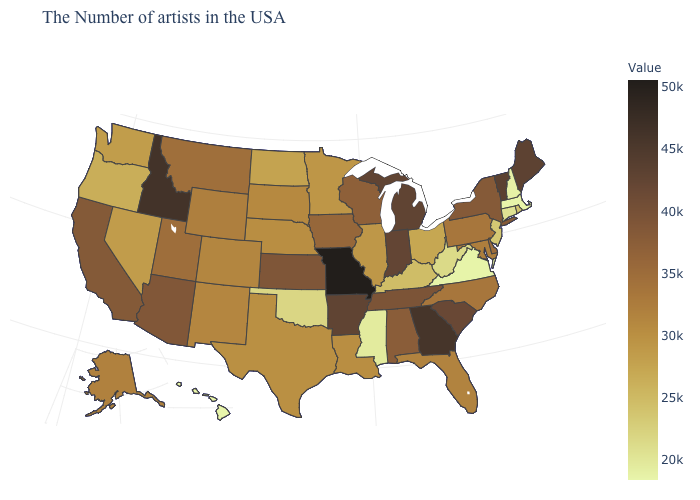Among the states that border South Carolina , does North Carolina have the lowest value?
Concise answer only. Yes. Does Texas have a lower value than South Carolina?
Quick response, please. Yes. Does the map have missing data?
Short answer required. No. Which states hav the highest value in the Northeast?
Give a very brief answer. Vermont. Does Montana have a higher value than Indiana?
Answer briefly. No. Does Missouri have the highest value in the USA?
Answer briefly. Yes. Among the states that border Iowa , does Illinois have the lowest value?
Keep it brief. Yes. Which states have the lowest value in the USA?
Answer briefly. Hawaii. 